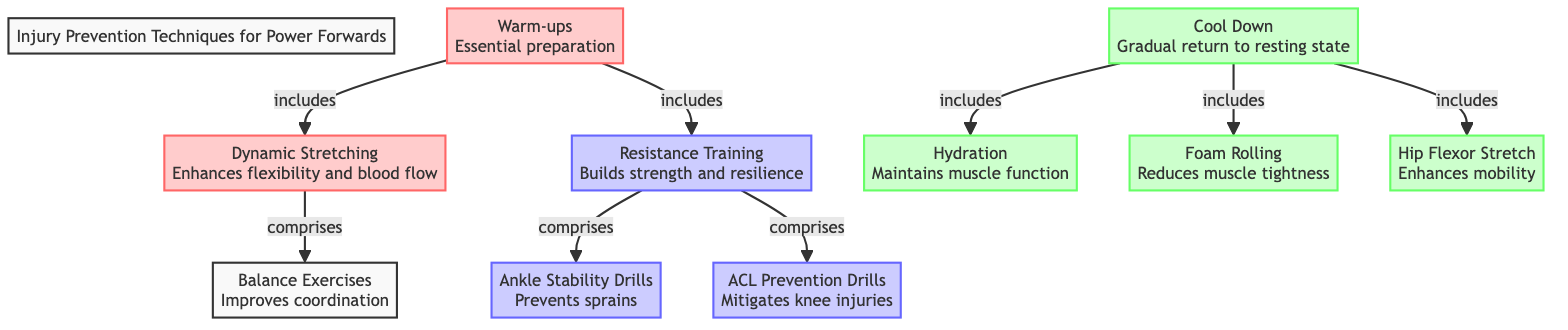What are the primary components included in warm-ups? The diagram indicates that warm-ups include dynamic stretching and resistance training, as denoted by the arrows pointing to these activities from the warm-ups node.
Answer: dynamic stretching, resistance training How many techniques are outlined under cool down? Looking at the cool down node, it includes foam rolling, hydration, and hip flexor stretch, which totals three techniques.
Answer: 3 Which type of training primarily consists of ankle stability drills? The resistance training node points to the ankle stability drills node, indicating that these drills are part of resistance training.
Answer: resistance training What is the main purpose of dynamic stretching according to the diagram? The description of dynamic stretching directly states that it enhances flexibility and blood flow, summarizing its main purpose.
Answer: Enhances flexibility and blood flow Which technique is designed to prevent sprains? The diagram highlights that ankle stability drills are specifically aimed at preventing sprains as mentioned in its description.
Answer: ankle stability drills What does the cool down process include that helps maintain muscle function? The hydration node within the cool down section indicates its role in maintaining muscle function, making it a key component.
Answer: hydration What relationship exists between dynamic stretching and balance exercises? Dynamic stretching incorporates balance exercises as part of its techniques, as shown by the arrows connecting them in the diagram.
Answer: comprises How many resistance training techniques are listed in the diagram? The resistance training node lists two techniques, which are ankle stability drills and ACL prevention drills, summing up to two.
Answer: 2 Which technique is suggested for mitigating knee injuries? The diagram specifies that ACL prevention drills are intended for mitigating knee injuries, clearly outlined under the resistance training section.
Answer: ACL prevention drills 